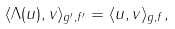<formula> <loc_0><loc_0><loc_500><loc_500>\langle \Lambda ( u ) , v \rangle _ { g ^ { \prime } , f ^ { \prime } } = \langle u , v \rangle _ { g , f } ,</formula> 